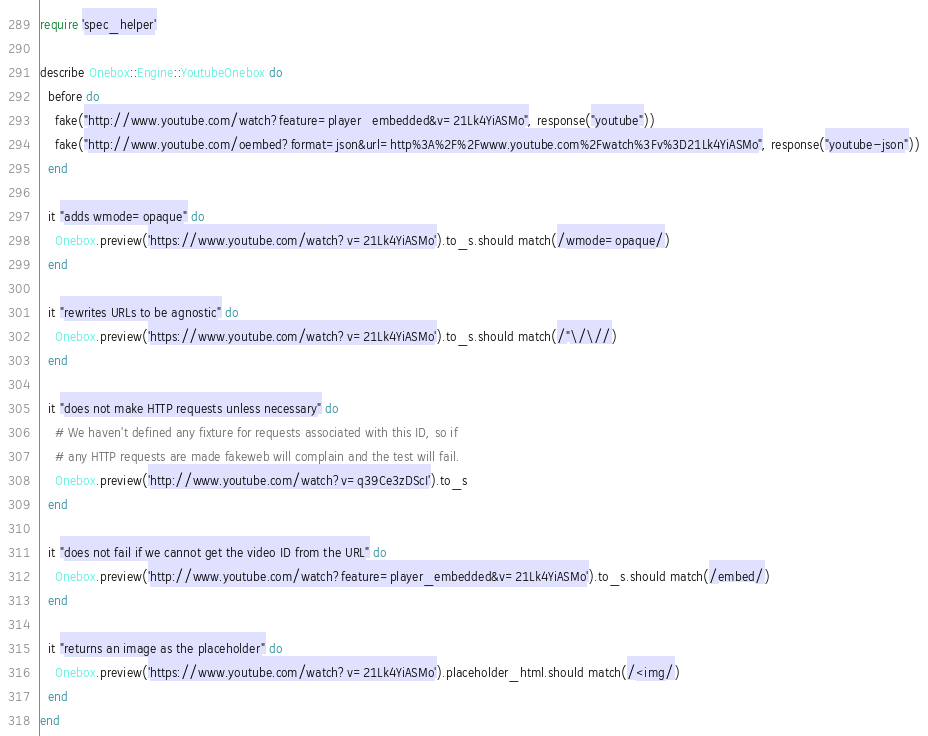<code> <loc_0><loc_0><loc_500><loc_500><_Ruby_>require 'spec_helper'

describe Onebox::Engine::YoutubeOnebox do
  before do
    fake("http://www.youtube.com/watch?feature=player_embedded&v=21Lk4YiASMo", response("youtube"))
    fake("http://www.youtube.com/oembed?format=json&url=http%3A%2F%2Fwww.youtube.com%2Fwatch%3Fv%3D21Lk4YiASMo", response("youtube-json"))
  end

  it "adds wmode=opaque" do
    Onebox.preview('https://www.youtube.com/watch?v=21Lk4YiASMo').to_s.should match(/wmode=opaque/)
  end

  it "rewrites URLs to be agnostic" do
    Onebox.preview('https://www.youtube.com/watch?v=21Lk4YiASMo').to_s.should match(/"\/\//)
  end

  it "does not make HTTP requests unless necessary" do
    # We haven't defined any fixture for requests associated with this ID, so if
    # any HTTP requests are made fakeweb will complain and the test will fail.
    Onebox.preview('http://www.youtube.com/watch?v=q39Ce3zDScI').to_s
  end

  it "does not fail if we cannot get the video ID from the URL" do
    Onebox.preview('http://www.youtube.com/watch?feature=player_embedded&v=21Lk4YiASMo').to_s.should match(/embed/)
  end

  it "returns an image as the placeholder" do
    Onebox.preview('https://www.youtube.com/watch?v=21Lk4YiASMo').placeholder_html.should match(/<img/)
  end
end

</code> 